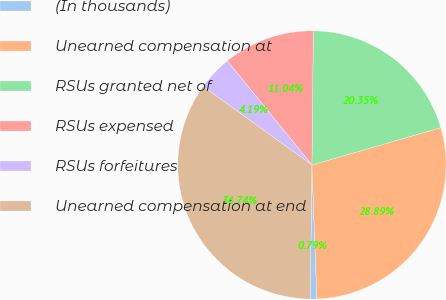Convert chart to OTSL. <chart><loc_0><loc_0><loc_500><loc_500><pie_chart><fcel>(In thousands)<fcel>Unearned compensation at<fcel>RSUs granted net of<fcel>RSUs expensed<fcel>RSUs forfeitures<fcel>Unearned compensation at end<nl><fcel>0.79%<fcel>28.89%<fcel>20.35%<fcel>11.04%<fcel>4.19%<fcel>34.74%<nl></chart> 